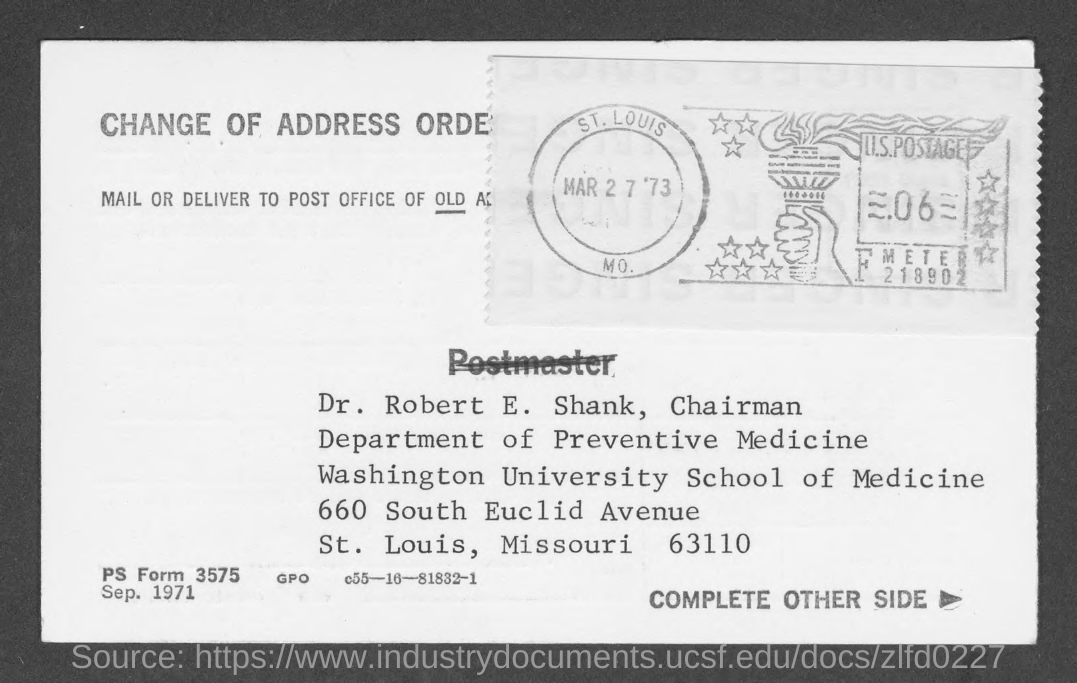What is the name mentioned in the given form ?
Your response must be concise. Dr. Robert E. Shank. What is the designation of  dr. robert e. shank ?
Give a very brief answer. Chairman. What is the name of the department mentioned in the given page ?
Offer a very short reply. Department of preventive medicine. What is the university mentioned in the given page ?
Give a very brief answer. Washington University. What is the date mentioned in the given page ?
Ensure brevity in your answer.  Mar 27 '73. 